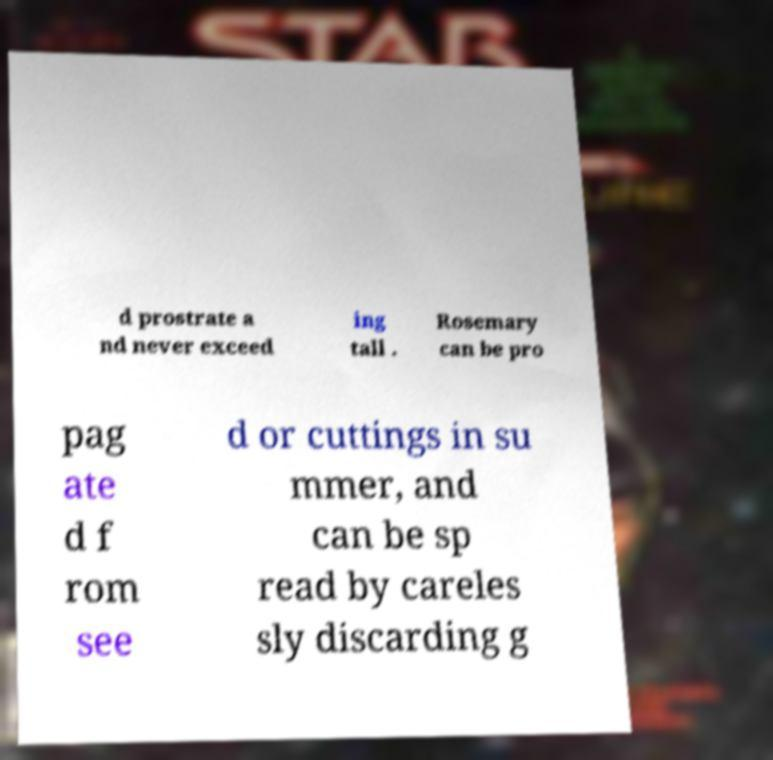Can you accurately transcribe the text from the provided image for me? d prostrate a nd never exceed ing tall . Rosemary can be pro pag ate d f rom see d or cuttings in su mmer, and can be sp read by careles sly discarding g 